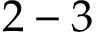<formula> <loc_0><loc_0><loc_500><loc_500>2 - 3</formula> 